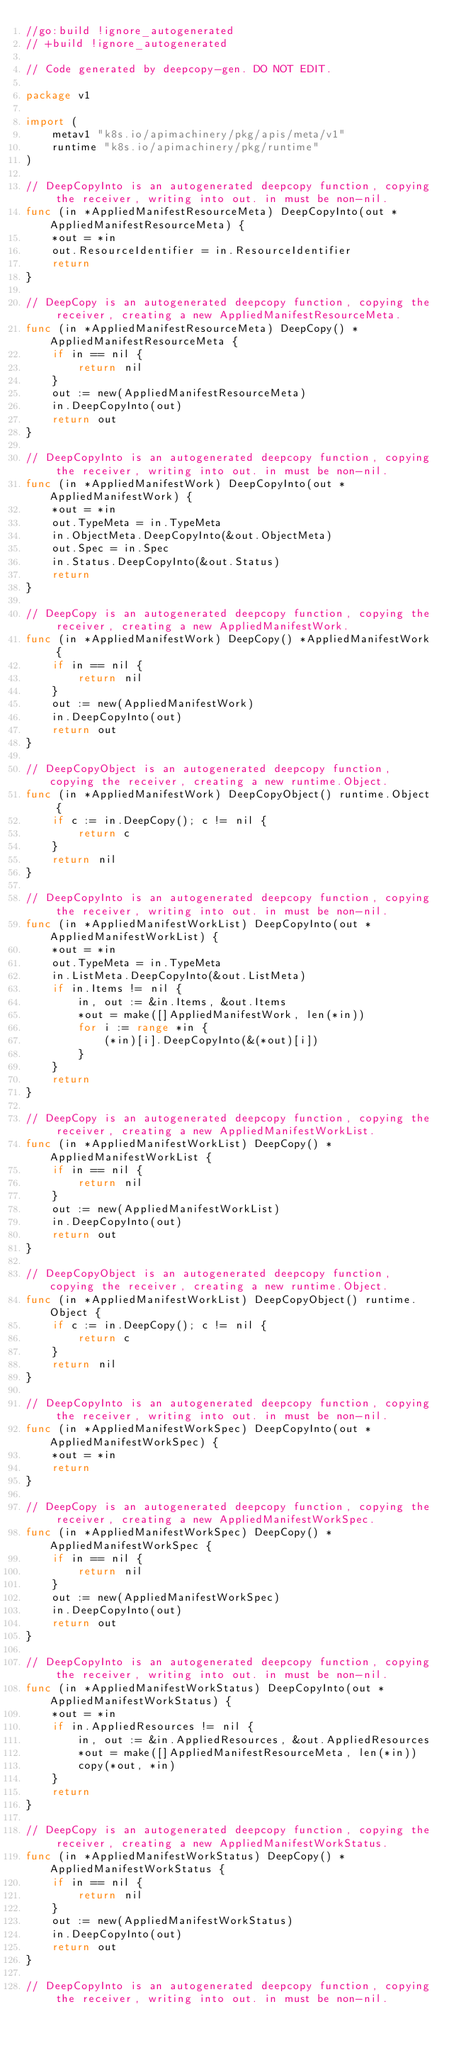<code> <loc_0><loc_0><loc_500><loc_500><_Go_>//go:build !ignore_autogenerated
// +build !ignore_autogenerated

// Code generated by deepcopy-gen. DO NOT EDIT.

package v1

import (
	metav1 "k8s.io/apimachinery/pkg/apis/meta/v1"
	runtime "k8s.io/apimachinery/pkg/runtime"
)

// DeepCopyInto is an autogenerated deepcopy function, copying the receiver, writing into out. in must be non-nil.
func (in *AppliedManifestResourceMeta) DeepCopyInto(out *AppliedManifestResourceMeta) {
	*out = *in
	out.ResourceIdentifier = in.ResourceIdentifier
	return
}

// DeepCopy is an autogenerated deepcopy function, copying the receiver, creating a new AppliedManifestResourceMeta.
func (in *AppliedManifestResourceMeta) DeepCopy() *AppliedManifestResourceMeta {
	if in == nil {
		return nil
	}
	out := new(AppliedManifestResourceMeta)
	in.DeepCopyInto(out)
	return out
}

// DeepCopyInto is an autogenerated deepcopy function, copying the receiver, writing into out. in must be non-nil.
func (in *AppliedManifestWork) DeepCopyInto(out *AppliedManifestWork) {
	*out = *in
	out.TypeMeta = in.TypeMeta
	in.ObjectMeta.DeepCopyInto(&out.ObjectMeta)
	out.Spec = in.Spec
	in.Status.DeepCopyInto(&out.Status)
	return
}

// DeepCopy is an autogenerated deepcopy function, copying the receiver, creating a new AppliedManifestWork.
func (in *AppliedManifestWork) DeepCopy() *AppliedManifestWork {
	if in == nil {
		return nil
	}
	out := new(AppliedManifestWork)
	in.DeepCopyInto(out)
	return out
}

// DeepCopyObject is an autogenerated deepcopy function, copying the receiver, creating a new runtime.Object.
func (in *AppliedManifestWork) DeepCopyObject() runtime.Object {
	if c := in.DeepCopy(); c != nil {
		return c
	}
	return nil
}

// DeepCopyInto is an autogenerated deepcopy function, copying the receiver, writing into out. in must be non-nil.
func (in *AppliedManifestWorkList) DeepCopyInto(out *AppliedManifestWorkList) {
	*out = *in
	out.TypeMeta = in.TypeMeta
	in.ListMeta.DeepCopyInto(&out.ListMeta)
	if in.Items != nil {
		in, out := &in.Items, &out.Items
		*out = make([]AppliedManifestWork, len(*in))
		for i := range *in {
			(*in)[i].DeepCopyInto(&(*out)[i])
		}
	}
	return
}

// DeepCopy is an autogenerated deepcopy function, copying the receiver, creating a new AppliedManifestWorkList.
func (in *AppliedManifestWorkList) DeepCopy() *AppliedManifestWorkList {
	if in == nil {
		return nil
	}
	out := new(AppliedManifestWorkList)
	in.DeepCopyInto(out)
	return out
}

// DeepCopyObject is an autogenerated deepcopy function, copying the receiver, creating a new runtime.Object.
func (in *AppliedManifestWorkList) DeepCopyObject() runtime.Object {
	if c := in.DeepCopy(); c != nil {
		return c
	}
	return nil
}

// DeepCopyInto is an autogenerated deepcopy function, copying the receiver, writing into out. in must be non-nil.
func (in *AppliedManifestWorkSpec) DeepCopyInto(out *AppliedManifestWorkSpec) {
	*out = *in
	return
}

// DeepCopy is an autogenerated deepcopy function, copying the receiver, creating a new AppliedManifestWorkSpec.
func (in *AppliedManifestWorkSpec) DeepCopy() *AppliedManifestWorkSpec {
	if in == nil {
		return nil
	}
	out := new(AppliedManifestWorkSpec)
	in.DeepCopyInto(out)
	return out
}

// DeepCopyInto is an autogenerated deepcopy function, copying the receiver, writing into out. in must be non-nil.
func (in *AppliedManifestWorkStatus) DeepCopyInto(out *AppliedManifestWorkStatus) {
	*out = *in
	if in.AppliedResources != nil {
		in, out := &in.AppliedResources, &out.AppliedResources
		*out = make([]AppliedManifestResourceMeta, len(*in))
		copy(*out, *in)
	}
	return
}

// DeepCopy is an autogenerated deepcopy function, copying the receiver, creating a new AppliedManifestWorkStatus.
func (in *AppliedManifestWorkStatus) DeepCopy() *AppliedManifestWorkStatus {
	if in == nil {
		return nil
	}
	out := new(AppliedManifestWorkStatus)
	in.DeepCopyInto(out)
	return out
}

// DeepCopyInto is an autogenerated deepcopy function, copying the receiver, writing into out. in must be non-nil.</code> 